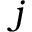<formula> <loc_0><loc_0><loc_500><loc_500>j</formula> 